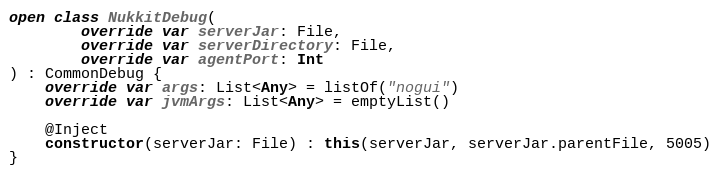Convert code to text. <code><loc_0><loc_0><loc_500><loc_500><_Kotlin_>
open class NukkitDebug(
        override var serverJar: File,
        override var serverDirectory: File,
        override var agentPort: Int
) : CommonDebug {
    override var args: List<Any> = listOf("nogui")
    override var jvmArgs: List<Any> = emptyList()

    @Inject
    constructor(serverJar: File) : this(serverJar, serverJar.parentFile, 5005)
}</code> 